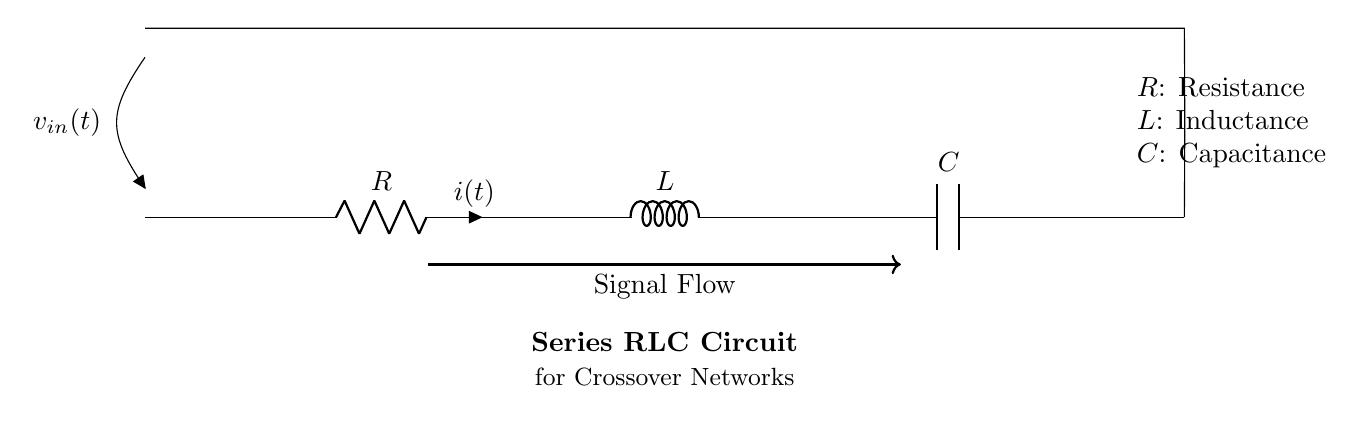What are the components shown in the circuit? The components in the circuit are a resistor, an inductor, and a capacitor arranged in series.
Answer: resistor, inductor, capacitor What is the input voltage denoted as? The input voltage in the circuit is denoted as v-in(t), which indicates it's a time-varying signal.
Answer: v-in(t) What does the 'i' symbol represent? The 'i' symbol in the circuit indicates the current flowing through the resistor, which is a function of time denoted as i(t).
Answer: i(t) How are the components connected in the circuit? The components are connected in series, meaning they are connected one after the other, forming a single path for current flow.
Answer: in series What is the relationship between resistance, inductance, and capacitance in this circuit? In a series RLC circuit, the overall impedance is determined by the combined effects of resistance, inductance, and capacitance, which affects the current and voltage behavior.
Answer: affects impedance What is the purpose of using this RLC configuration in speaker systems? The RLC configuration is used as a crossover network to filter audio signals, allowing only certain frequency ranges to pass through to the appropriate speaker drivers.
Answer: filter audio signals What phenomenon occurs at the resonant frequency in this RLC circuit? At the resonant frequency, the circuit experiences maximum current flow as the inductive and capacitive reactances cancel each other out.
Answer: maximum current flow 